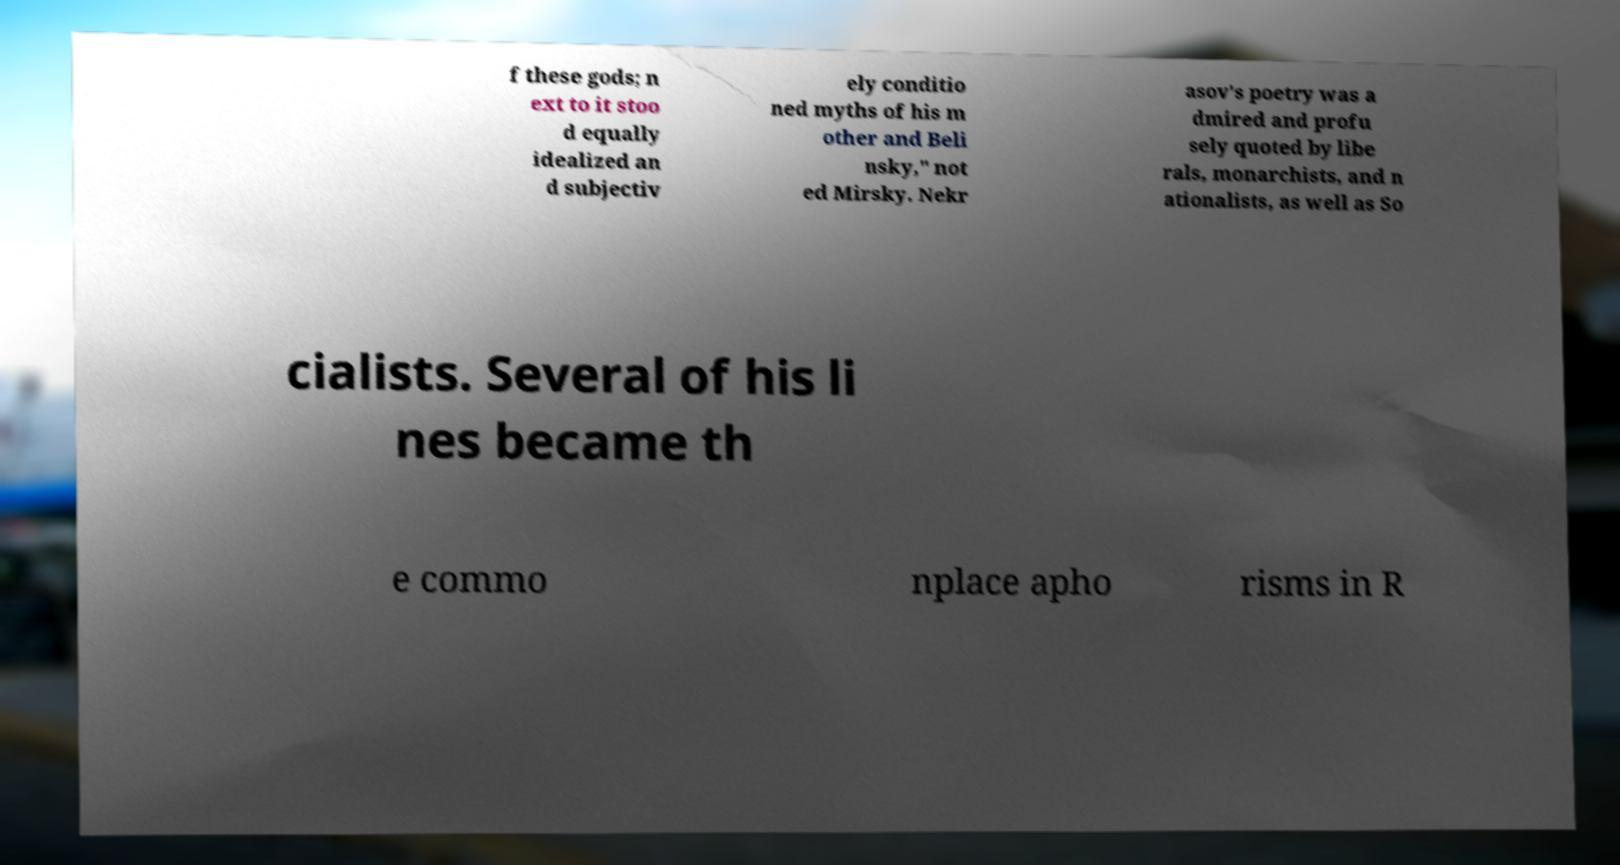Can you accurately transcribe the text from the provided image for me? f these gods; n ext to it stoo d equally idealized an d subjectiv ely conditio ned myths of his m other and Beli nsky," not ed Mirsky. Nekr asov's poetry was a dmired and profu sely quoted by libe rals, monarchists, and n ationalists, as well as So cialists. Several of his li nes became th e commo nplace apho risms in R 